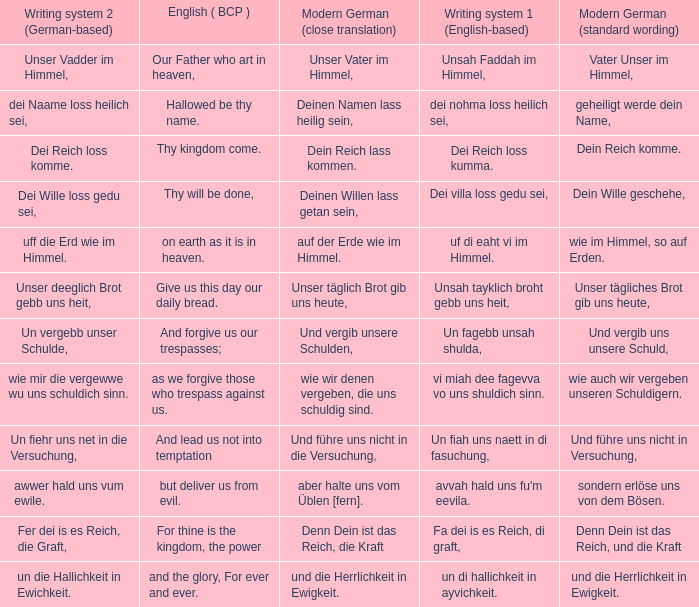What is the english (bcp) phrase "for thine is the kingdom, the power" in modern german with standard wording? Denn Dein ist das Reich, und die Kraft. 